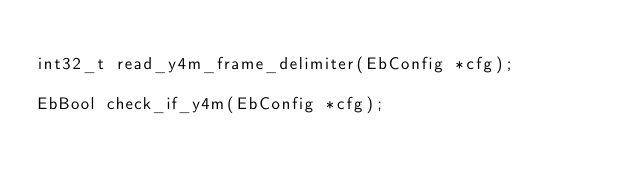<code> <loc_0><loc_0><loc_500><loc_500><_C_>
int32_t read_y4m_frame_delimiter(EbConfig *cfg);

EbBool check_if_y4m(EbConfig *cfg);
</code> 